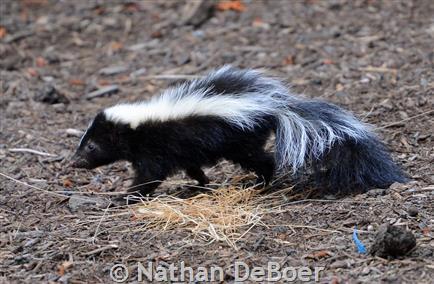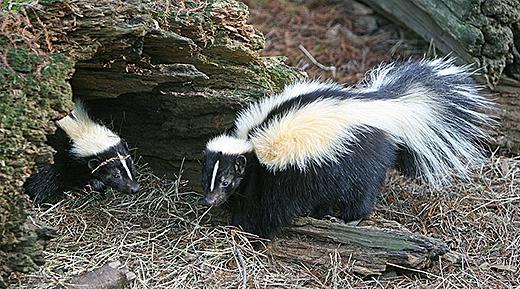The first image is the image on the left, the second image is the image on the right. Analyze the images presented: Is the assertion "there is a skunk peaking out from a fallen tree trunk with just the front part of it's bidy visible" valid? Answer yes or no. Yes. 